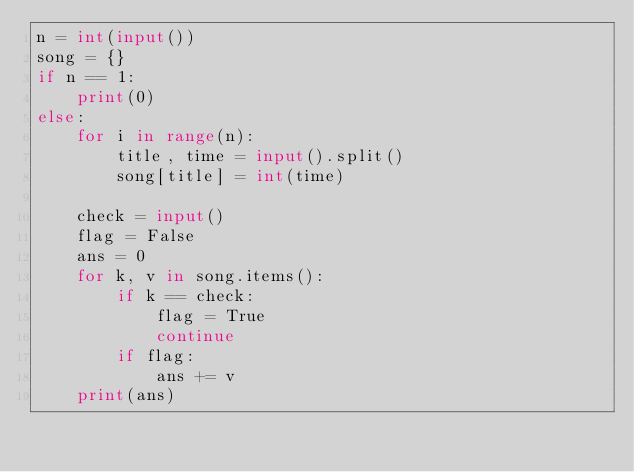Convert code to text. <code><loc_0><loc_0><loc_500><loc_500><_Python_>n = int(input())
song = {}
if n == 1:
    print(0)
else:
    for i in range(n):
        title, time = input().split()
        song[title] = int(time)

    check = input()
    flag = False
    ans = 0
    for k, v in song.items():
        if k == check:
            flag = True
            continue
        if flag:
            ans += v
    print(ans)
</code> 